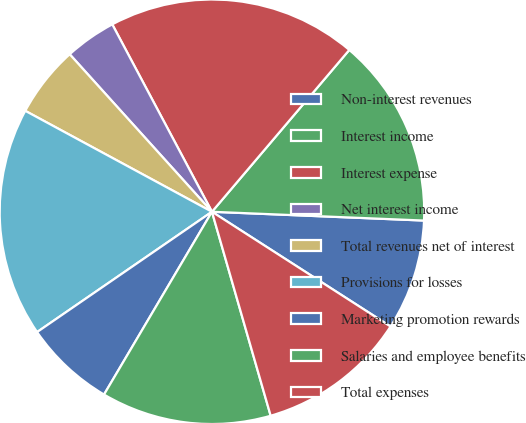Convert chart. <chart><loc_0><loc_0><loc_500><loc_500><pie_chart><fcel>Non-interest revenues<fcel>Interest income<fcel>Interest expense<fcel>Net interest income<fcel>Total revenues net of interest<fcel>Provisions for losses<fcel>Marketing promotion rewards<fcel>Salaries and employee benefits<fcel>Total expenses<nl><fcel>8.43%<fcel>14.46%<fcel>18.98%<fcel>3.91%<fcel>5.42%<fcel>17.48%<fcel>6.92%<fcel>12.95%<fcel>11.45%<nl></chart> 